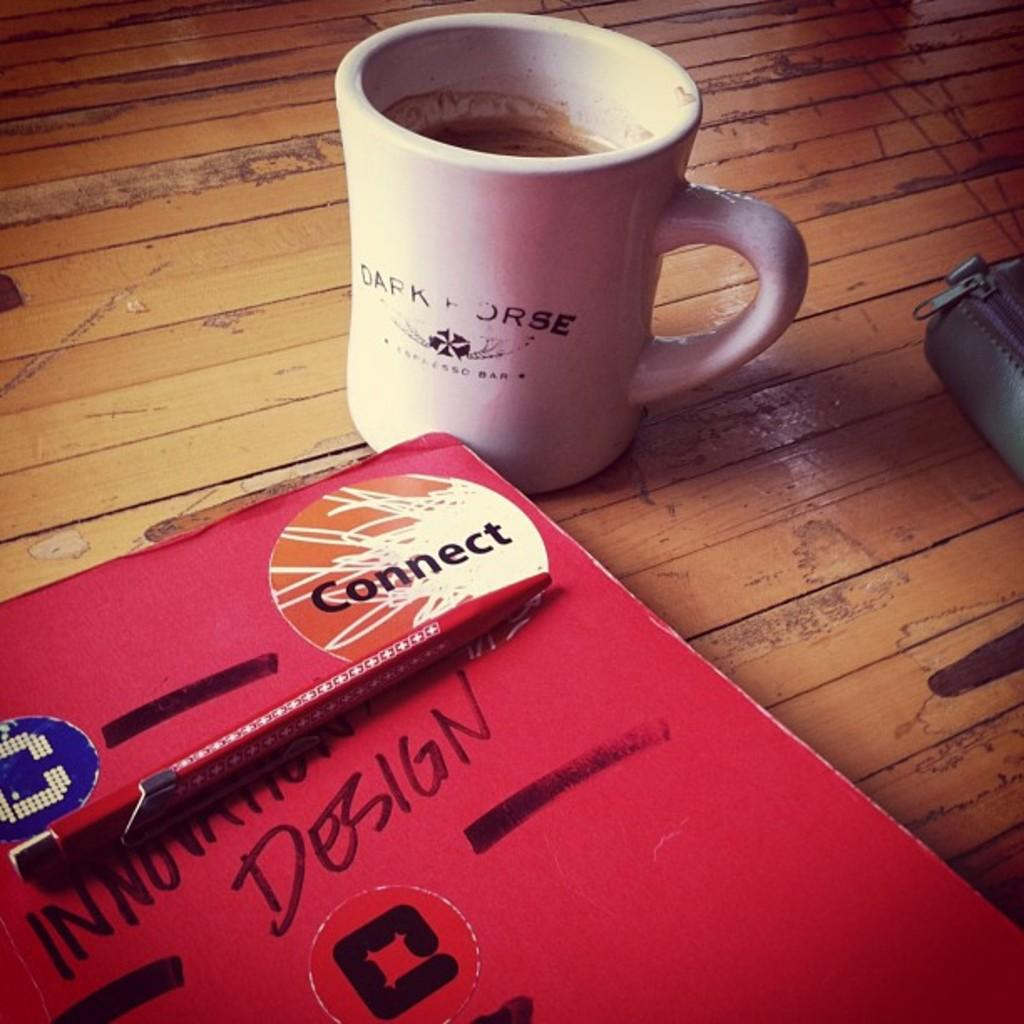<image>
Offer a succinct explanation of the picture presented. a red book next to voffe with the word connect on it 